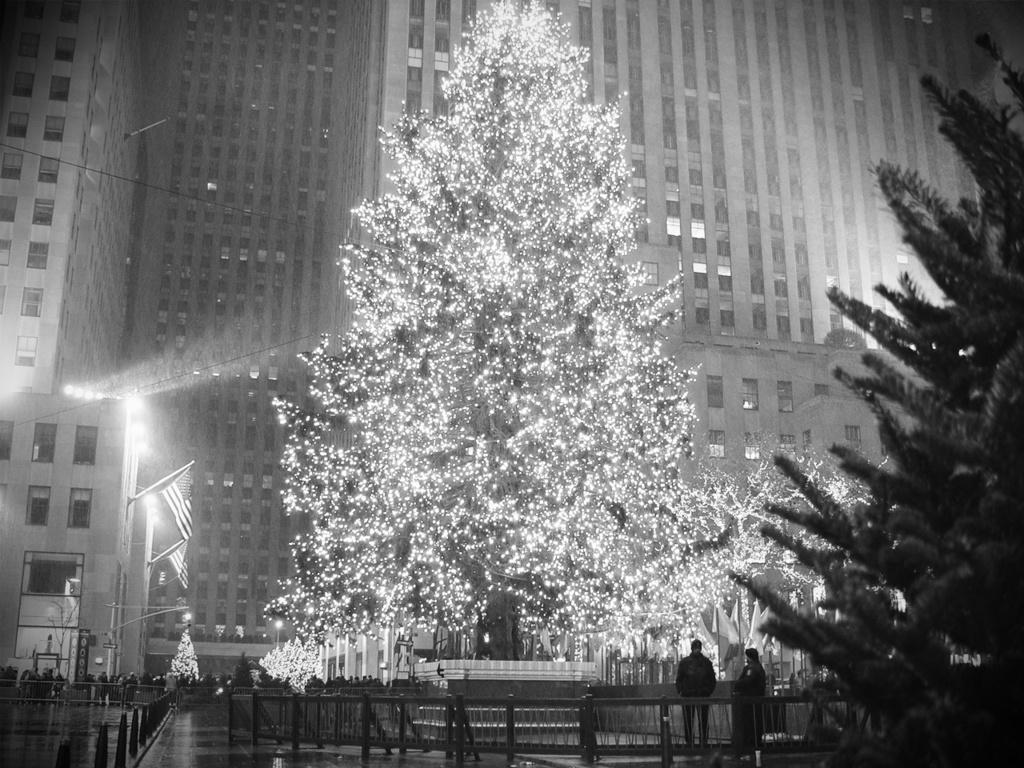What is the color scheme of the image? The image is black and white. How many flags are present in the image? There are three flags in the image. What type of structures can be seen in the image? There are light poles, railings, and buildings in the image. Are there any people in the image? Yes, there are people in the image. What other objects can be seen in the image? There are boards, decorative lights, and unspecified objects in the image. What suggestion does the son make in the image? There is no son present in the image, and therefore no suggestion can be attributed to him. 